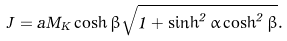<formula> <loc_0><loc_0><loc_500><loc_500>J = a M _ { K } \cosh \beta \sqrt { 1 + \sinh ^ { 2 } \alpha \cosh ^ { 2 } \beta } .</formula> 